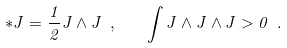<formula> <loc_0><loc_0><loc_500><loc_500>* J = \frac { 1 } { 2 } J \wedge J \ , \quad \int J \wedge J \wedge J > 0 \ .</formula> 